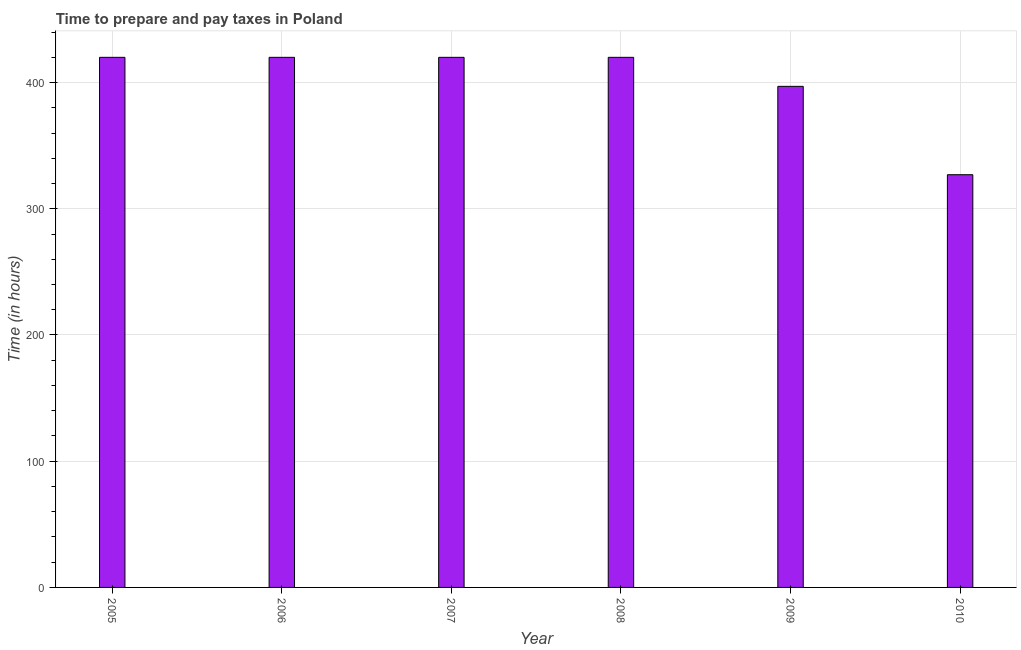Does the graph contain any zero values?
Provide a succinct answer. No. Does the graph contain grids?
Provide a short and direct response. Yes. What is the title of the graph?
Ensure brevity in your answer.  Time to prepare and pay taxes in Poland. What is the label or title of the Y-axis?
Give a very brief answer. Time (in hours). What is the time to prepare and pay taxes in 2008?
Offer a very short reply. 420. Across all years, what is the maximum time to prepare and pay taxes?
Your answer should be very brief. 420. Across all years, what is the minimum time to prepare and pay taxes?
Offer a very short reply. 327. What is the sum of the time to prepare and pay taxes?
Ensure brevity in your answer.  2404. What is the difference between the time to prepare and pay taxes in 2005 and 2007?
Offer a terse response. 0. What is the median time to prepare and pay taxes?
Give a very brief answer. 420. Do a majority of the years between 2009 and 2006 (inclusive) have time to prepare and pay taxes greater than 20 hours?
Provide a succinct answer. Yes. What is the ratio of the time to prepare and pay taxes in 2008 to that in 2010?
Offer a terse response. 1.28. Is the sum of the time to prepare and pay taxes in 2005 and 2010 greater than the maximum time to prepare and pay taxes across all years?
Your response must be concise. Yes. What is the difference between the highest and the lowest time to prepare and pay taxes?
Ensure brevity in your answer.  93. How many bars are there?
Provide a short and direct response. 6. Are all the bars in the graph horizontal?
Offer a terse response. No. What is the difference between two consecutive major ticks on the Y-axis?
Offer a very short reply. 100. What is the Time (in hours) of 2005?
Offer a very short reply. 420. What is the Time (in hours) of 2006?
Offer a terse response. 420. What is the Time (in hours) in 2007?
Keep it short and to the point. 420. What is the Time (in hours) in 2008?
Provide a short and direct response. 420. What is the Time (in hours) of 2009?
Provide a short and direct response. 397. What is the Time (in hours) of 2010?
Keep it short and to the point. 327. What is the difference between the Time (in hours) in 2005 and 2009?
Make the answer very short. 23. What is the difference between the Time (in hours) in 2005 and 2010?
Make the answer very short. 93. What is the difference between the Time (in hours) in 2006 and 2009?
Make the answer very short. 23. What is the difference between the Time (in hours) in 2006 and 2010?
Offer a very short reply. 93. What is the difference between the Time (in hours) in 2007 and 2008?
Ensure brevity in your answer.  0. What is the difference between the Time (in hours) in 2007 and 2009?
Keep it short and to the point. 23. What is the difference between the Time (in hours) in 2007 and 2010?
Offer a very short reply. 93. What is the difference between the Time (in hours) in 2008 and 2010?
Make the answer very short. 93. What is the difference between the Time (in hours) in 2009 and 2010?
Your answer should be compact. 70. What is the ratio of the Time (in hours) in 2005 to that in 2008?
Your answer should be very brief. 1. What is the ratio of the Time (in hours) in 2005 to that in 2009?
Your response must be concise. 1.06. What is the ratio of the Time (in hours) in 2005 to that in 2010?
Your answer should be compact. 1.28. What is the ratio of the Time (in hours) in 2006 to that in 2007?
Make the answer very short. 1. What is the ratio of the Time (in hours) in 2006 to that in 2008?
Provide a succinct answer. 1. What is the ratio of the Time (in hours) in 2006 to that in 2009?
Your answer should be compact. 1.06. What is the ratio of the Time (in hours) in 2006 to that in 2010?
Make the answer very short. 1.28. What is the ratio of the Time (in hours) in 2007 to that in 2008?
Your response must be concise. 1. What is the ratio of the Time (in hours) in 2007 to that in 2009?
Provide a short and direct response. 1.06. What is the ratio of the Time (in hours) in 2007 to that in 2010?
Your answer should be very brief. 1.28. What is the ratio of the Time (in hours) in 2008 to that in 2009?
Offer a very short reply. 1.06. What is the ratio of the Time (in hours) in 2008 to that in 2010?
Your answer should be very brief. 1.28. What is the ratio of the Time (in hours) in 2009 to that in 2010?
Your response must be concise. 1.21. 